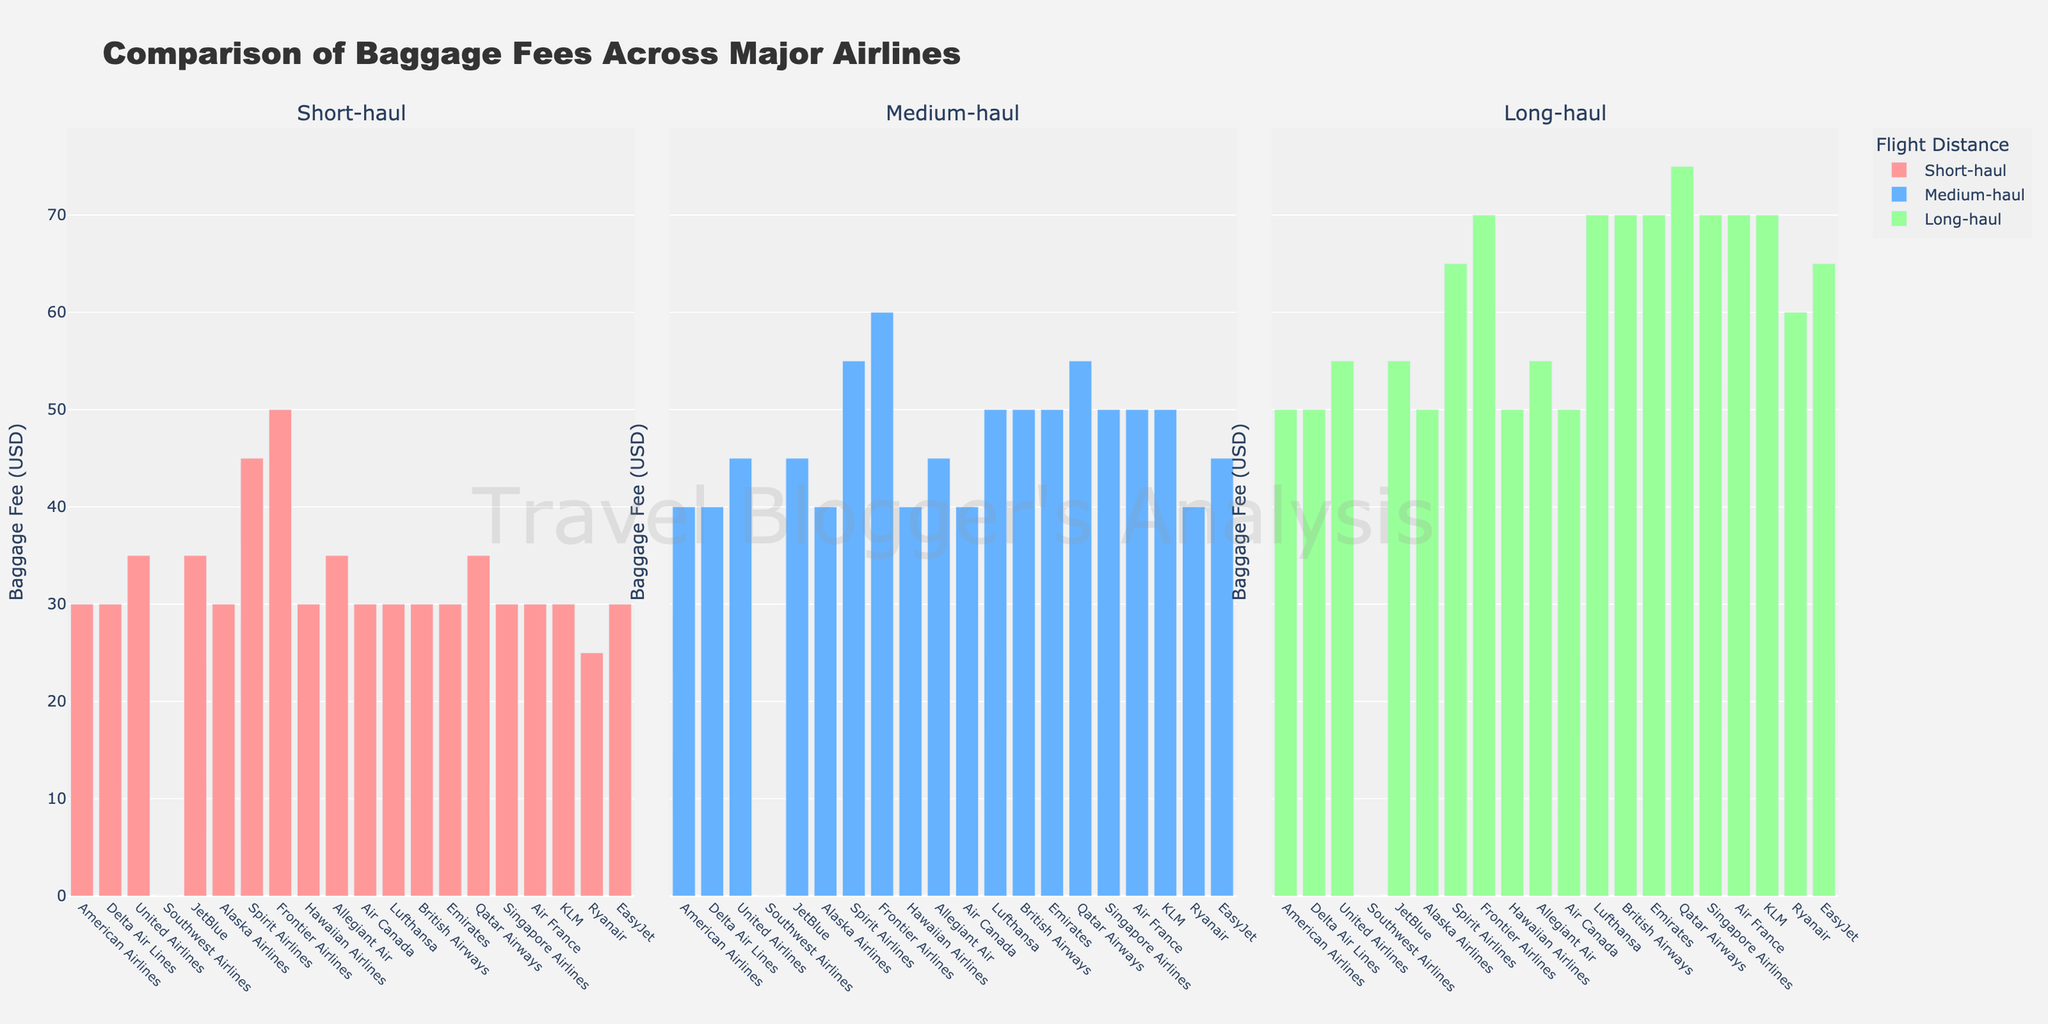How many airlines charge $30 for short-haul flights? To determine the number of airlines charging $30 for short-haul flights, count the bars in the leftmost plot that have a height corresponding to $30.
Answer: 12 Which airline has the highest baggage fee for medium-haul flights? Look at the bars in the middle plot and identify the one with the greatest height.
Answer: Frontier Airlines Is the baggage fee for long-haul flights higher for Spirit Airlines or Ryanair? Compare the heights of the bars corresponding to Spirit Airlines and Ryanair in the rightmost plot.
Answer: Spirit Airlines What's the average baggage fee for short-haul flights across all airlines? Sum all the baggage fees for short-haul flights and divide by the number of airlines: (30+30+35+0+35+30+45+50+30+35+30+30+30+30+35+30+30+30+25+30) / 20.
Answer: 31.5 Which three airlines have the same baggage fee structure across all flight distances, and what is the structure? Identify airlines with three bars of equal height in all plots: American Airlines, Delta Air Lines, and Alaska Airlines. The structure is: $30 for short-haul, $40 for medium-haul, and $50 for long-haul flights.
Answer: American Airlines, Delta Air Lines, and Alaska Airlines; $30, $40, $50 What's the difference between the highest and lowest baggage fees for long-haul flights? Identify the highest and lowest bars in the rightmost plot and subtract the smallest fee from the largest: $75 (Qatar Airways) - $0 (Southwest Airlines).
Answer: 75 How many airlines offer free baggage for short-haul flights? Count the number of bars in the leftmost plot with a height of $0.
Answer: 1 Which category (short-haul, medium-haul, or long-haul) has the most variation in baggage fees among airlines? Look at the spread of the bars in each plot. The rightmost plot (long-haul) has bars ranging from $0 to $75, indicating the most variation.
Answer: Long-haul Between JetBlue and United Airlines, which one consistently charges higher baggage fees across all flight distances? Compare the heights of the bars for JetBlue and United Airlines in all three plots (left, middle, and right).
Answer: United Airlines How many airlines have a baggage fee for long-haul flights equal to their short-haul fee increased by $40? Identify airlines where the bar in the rightmost plot is $40 higher than the bar in the leftmost plot.
Answer: 0 